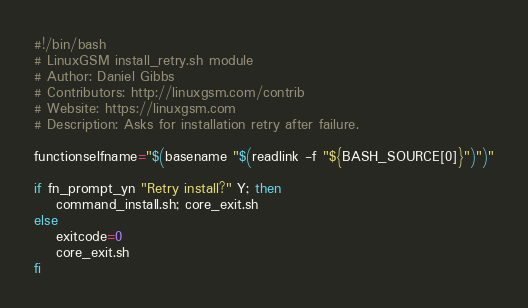Convert code to text. <code><loc_0><loc_0><loc_500><loc_500><_Bash_>#!/bin/bash
# LinuxGSM install_retry.sh module
# Author: Daniel Gibbs
# Contributors: http://linuxgsm.com/contrib
# Website: https://linuxgsm.com
# Description: Asks for installation retry after failure.

functionselfname="$(basename "$(readlink -f "${BASH_SOURCE[0]}")")"

if fn_prompt_yn "Retry install?" Y; then
	command_install.sh; core_exit.sh
else
	exitcode=0
	core_exit.sh
fi
</code> 